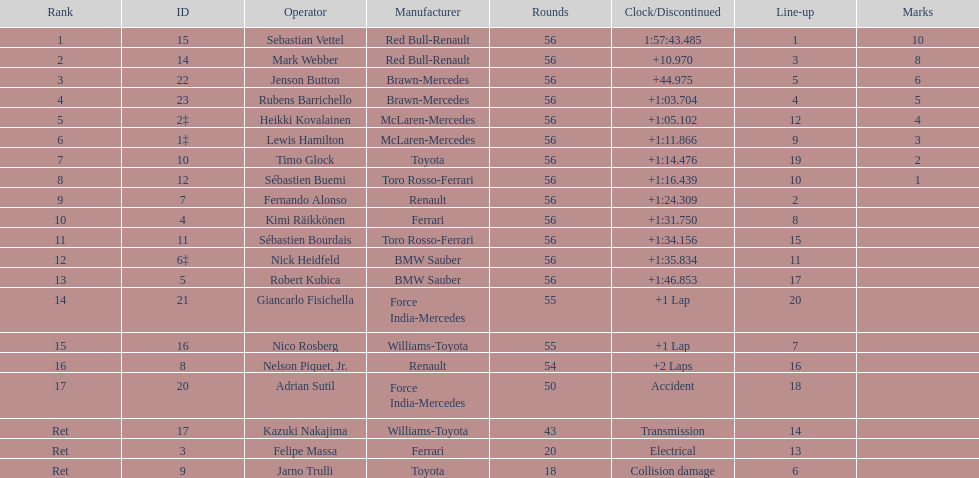What driver was last on the list? Jarno Trulli. 